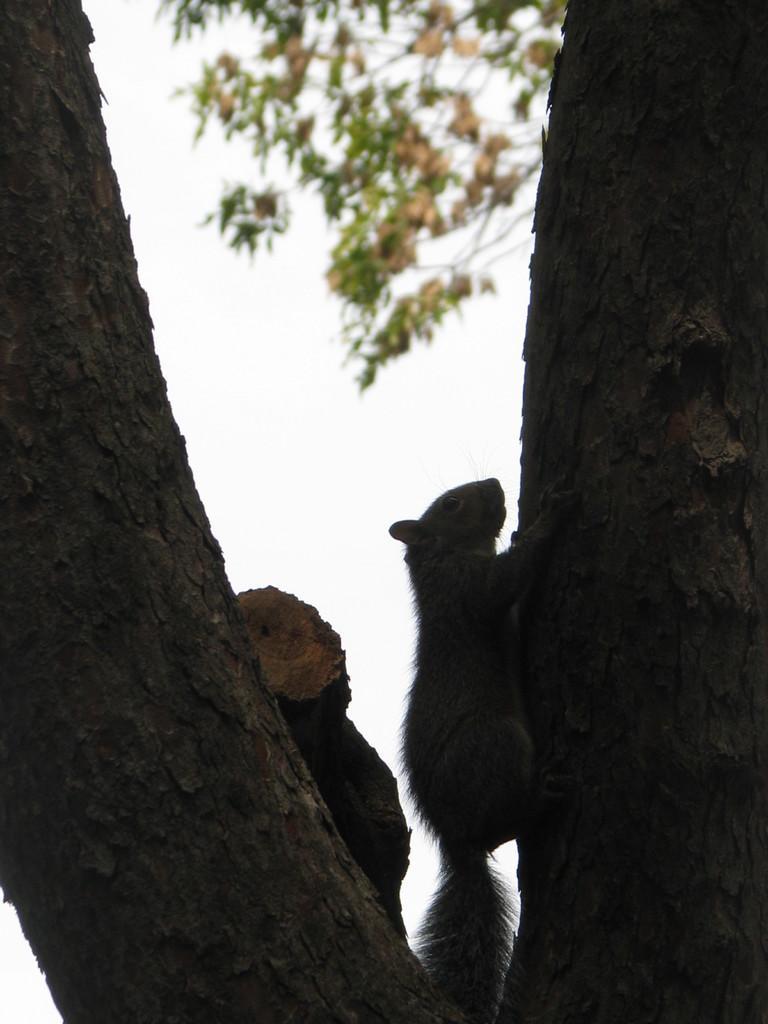Could you give a brief overview of what you see in this image? In the center of the image we can see a squirrel climbing a tree. In the background there is sky. 